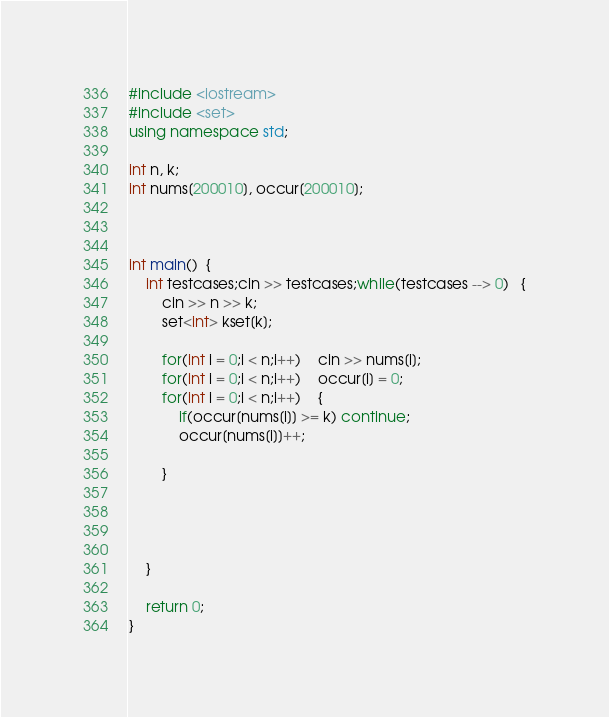Convert code to text. <code><loc_0><loc_0><loc_500><loc_500><_C++_>#include <iostream>
#include <set>
using namespace std;

int n, k;
int nums[200010], occur[200010];



int main()  {
    int testcases;cin >> testcases;while(testcases --> 0)   {
        cin >> n >> k;
        set<int> kset[k];

        for(int i = 0;i < n;i++)    cin >> nums[i];
        for(int i = 0;i < n;i++)    occur[i] = 0;
        for(int i = 0;i < n;i++)    {
            if(occur[nums[i]] >= k) continue;
            occur[nums[i]]++;

        }




    }

    return 0;
}</code> 